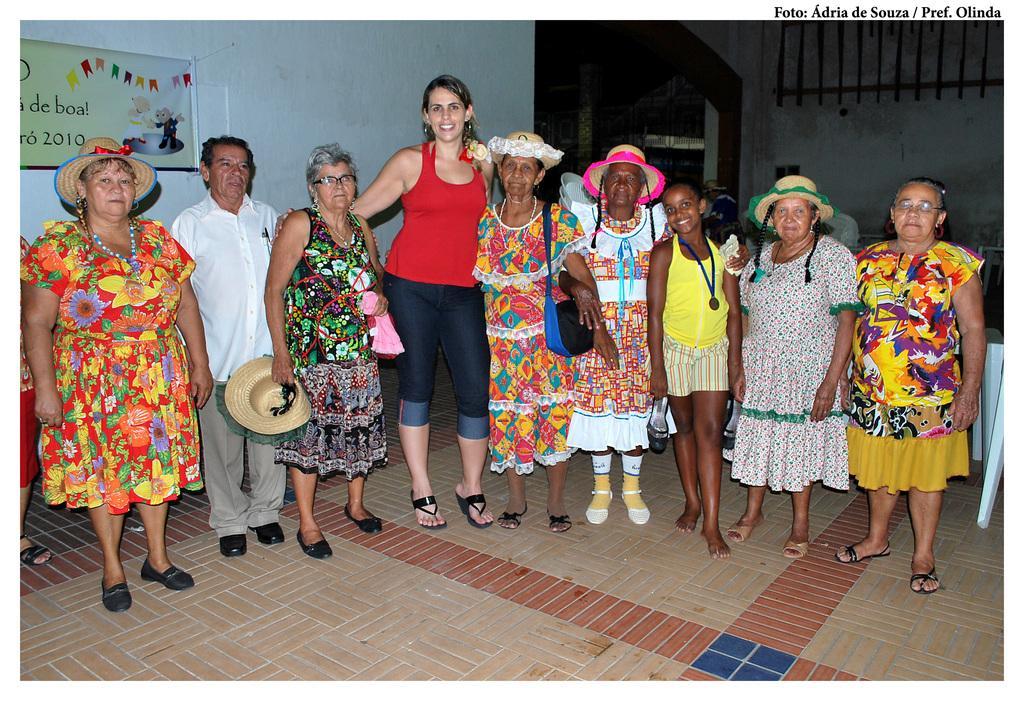In one or two sentences, can you explain what this image depicts? In this picture I can see group of people are standing on the floor. Among them some are wearing hats and some are carrying bags. In the background I can see a banner on the wall. On the right side I can see white color objects on the floor. 